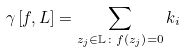<formula> <loc_0><loc_0><loc_500><loc_500>\gamma \left [ f , L \right ] = \sum _ { z _ { j } \in \mathbb { L } \colon f \left ( z _ { j } \right ) = 0 } k _ { i }</formula> 